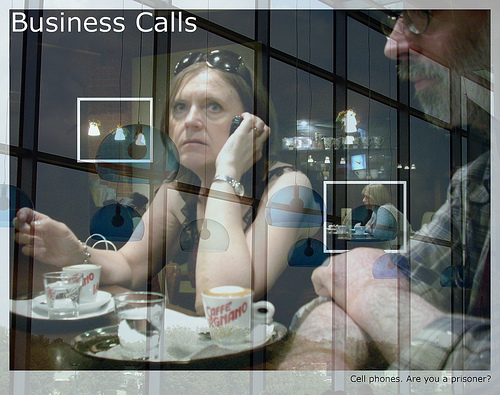Who is wearing glasses? The man is the one wearing glasses. 